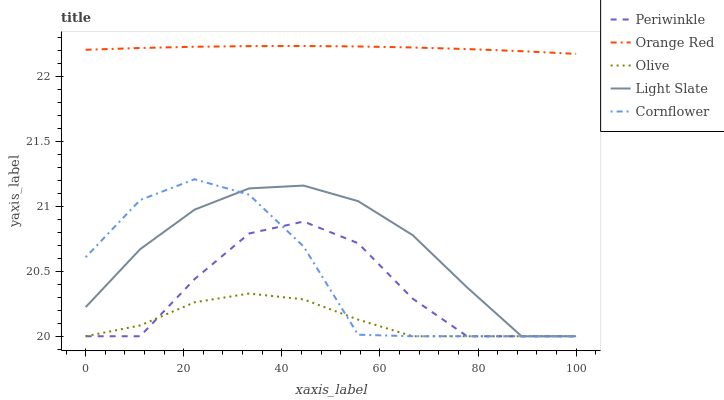Does Light Slate have the minimum area under the curve?
Answer yes or no. No. Does Light Slate have the maximum area under the curve?
Answer yes or no. No. Is Light Slate the smoothest?
Answer yes or no. No. Is Light Slate the roughest?
Answer yes or no. No. Does Orange Red have the lowest value?
Answer yes or no. No. Does Light Slate have the highest value?
Answer yes or no. No. Is Olive less than Orange Red?
Answer yes or no. Yes. Is Orange Red greater than Cornflower?
Answer yes or no. Yes. Does Olive intersect Orange Red?
Answer yes or no. No. 